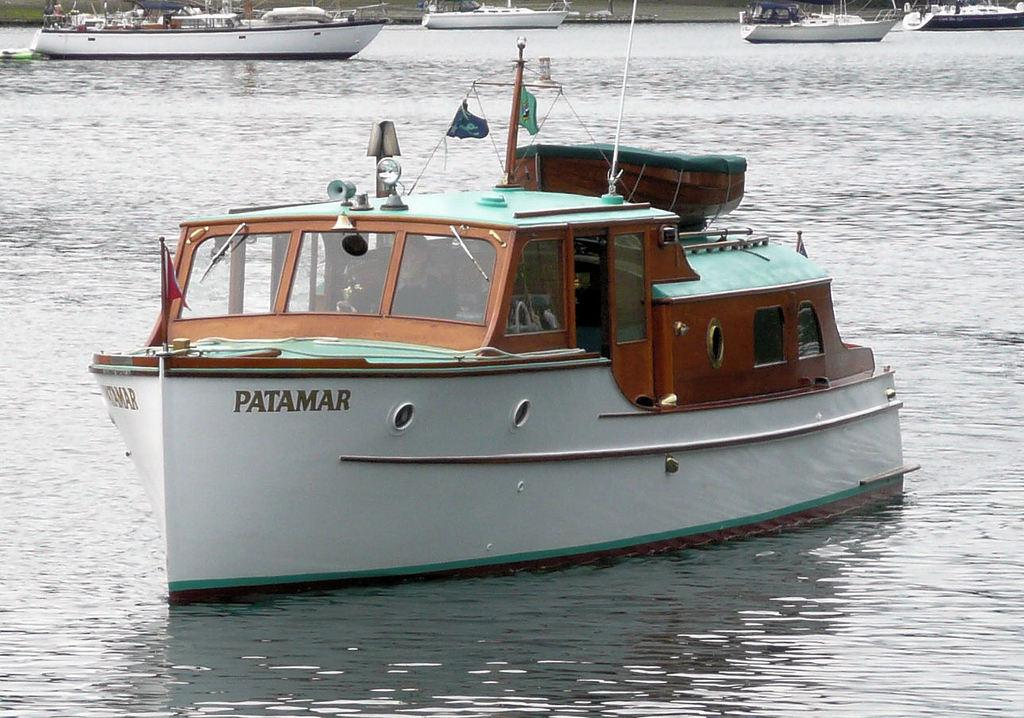What is the primary element in the image? There is water in the image. What is located in the middle of the water? There is a boat in the middle of the water. Can you describe the boats in the background? There are multiple boats visible in the background. What type of art can be seen hanging on the river during recess? There is no art or river present in the image, and the concept of recess does not apply to the scene. 